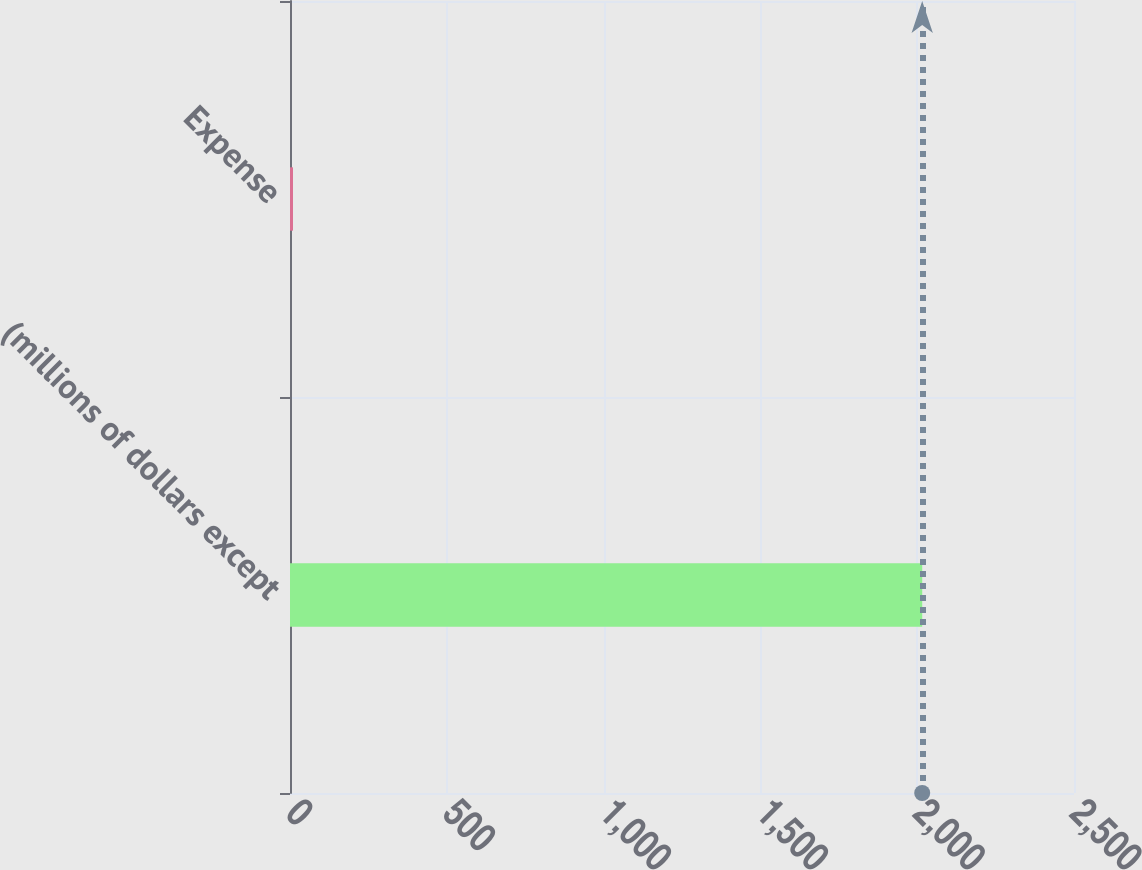Convert chart. <chart><loc_0><loc_0><loc_500><loc_500><bar_chart><fcel>(millions of dollars except<fcel>Expense<nl><fcel>2016<fcel>9.6<nl></chart> 